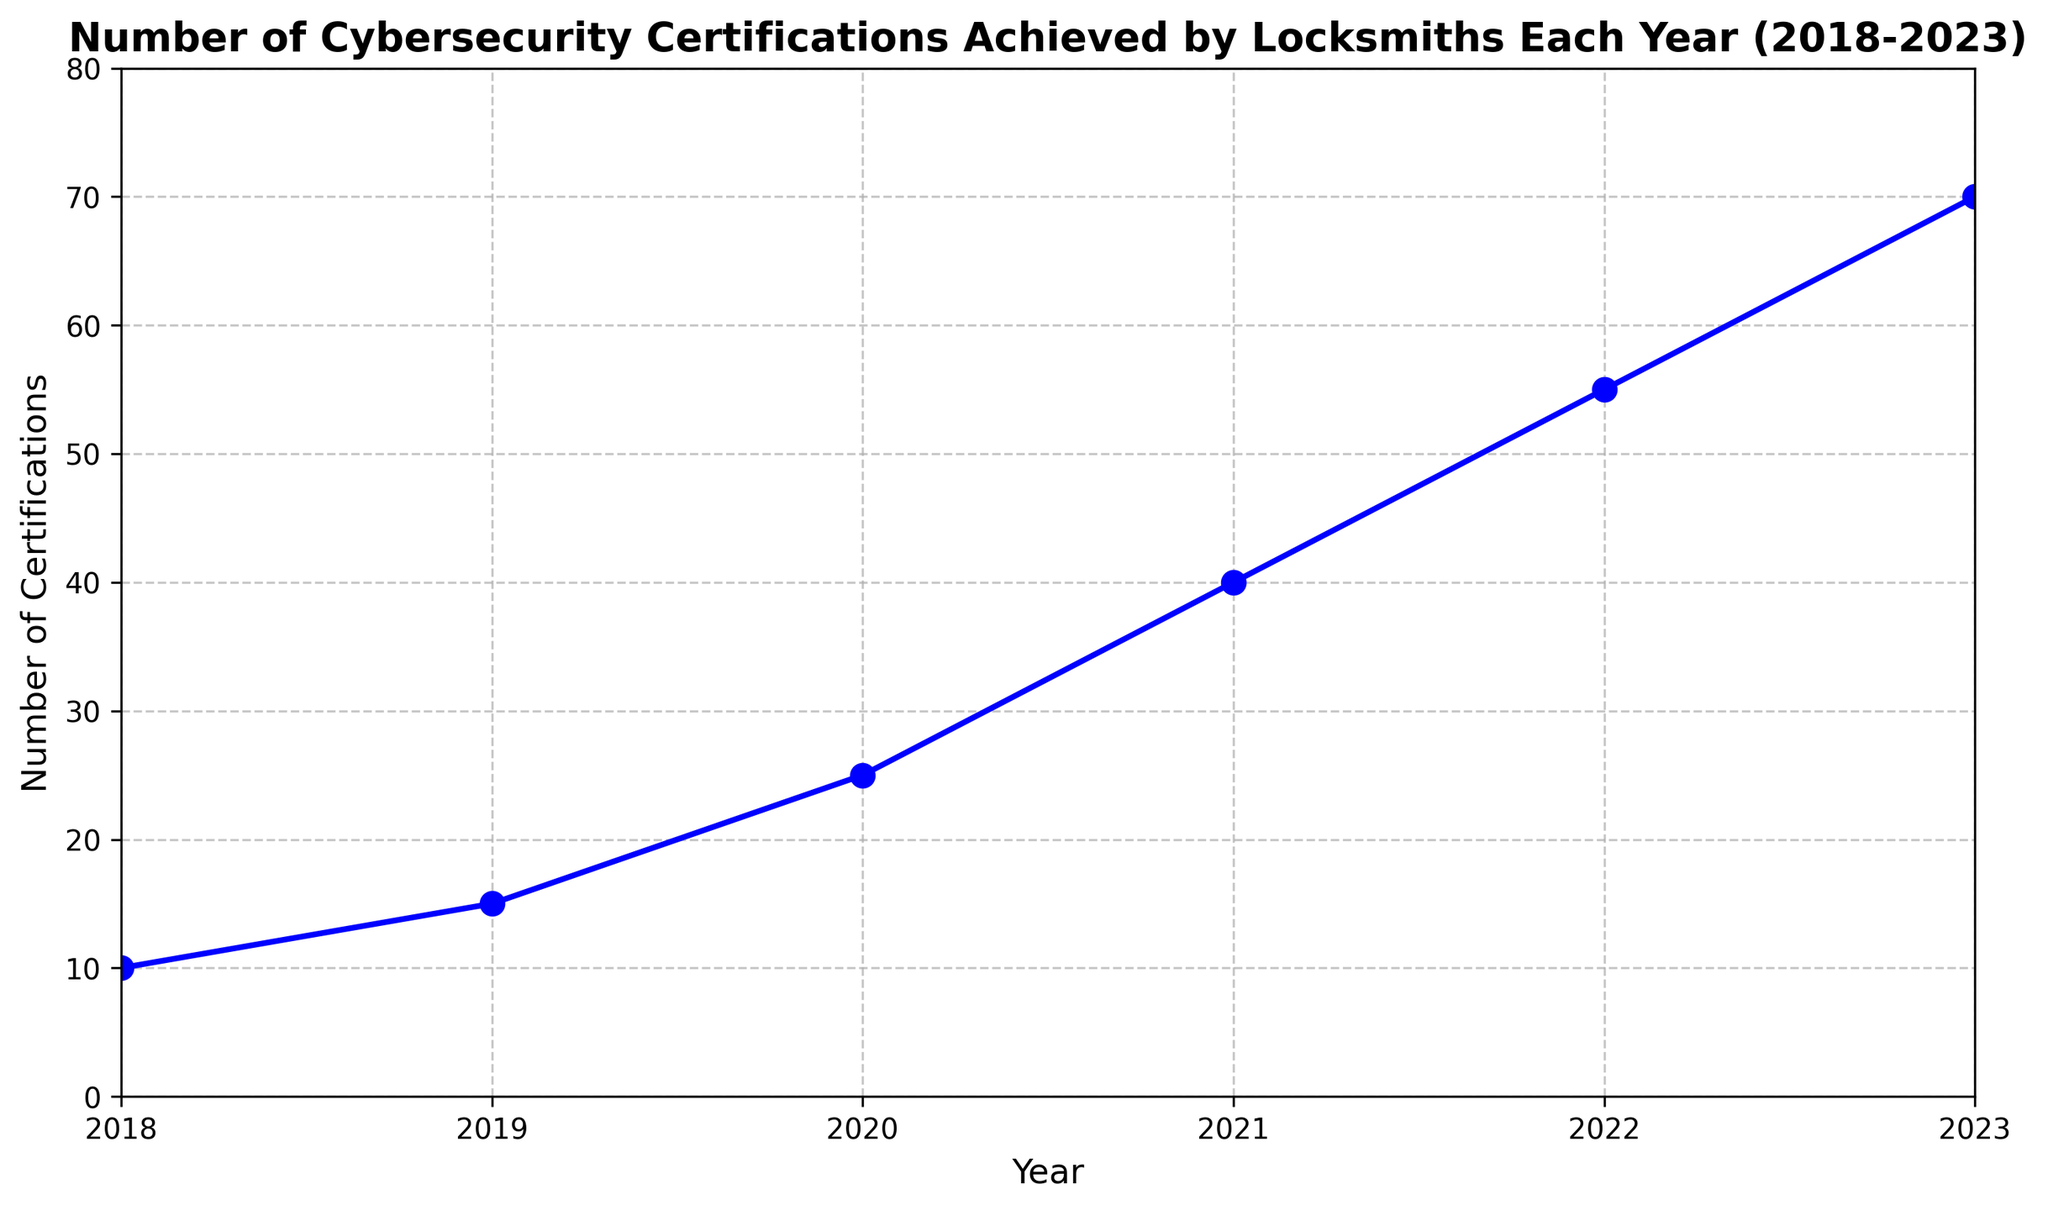What's the average number of certifications achieved per year from 2018 to 2023? To find the average number of certifications achieved per year from 2018 to 2023, sum up the values (10 + 15 + 25 + 40 + 55 + 70) = 215, then divide by the number of years, which is 6. Thus, 215 / 6 = approximately 35.83
Answer: 35.83 Which year had the greatest increase in certifications compared to the previous year? The increases each year are calculated as follows: (2019-2018) 15-10 = 5, (2020-2019) 25-15 = 10, (2021-2020) 40-25 = 15, (2022-2021) 55-40 = 15, (2023-2022) 70-55 = 15. The greatest increase occurred in 2021, 2022, and 2023, each with 15 certifications.
Answer: 2021, 2022, 2023 How many more certifications were achieved in 2020 compared to 2018? Subtract the number of certifications in 2018 from the number in 2020: 25 - 10 = 15. Therefore, 15 more certifications were achieved in 2020 compared to 2018
Answer: 15 What was the total number of certifications achieved in the first three years (2018-2020)? Sum the number of certifications from 2018, 2019, and 2020: 10 + 15 + 25 = 50. So, the total number for the first three years is 50
Answer: 50 What is the trend of the number of certifications over the years 2018 to 2023? The trend appears to be an increasing number of certifications each year, as each subsequent year shows a higher number of certifications than the previous year. Specifically, it increases from 10 in 2018 to 70 in 2023
Answer: Increasing Is the increase in certifications from 2021 to 2022 more than the increase from 2019 to 2020? Calculate the increases for each period: (2022-2021) 55-40 = 15 and (2020-2019) 25-15 = 10. Therefore, the increase from 2021 to 2022 (15) is greater than the increase from 2019 to 2020 (10)
Answer: Yes What visual element indicates a steady increase in certifications over time? The line on the chart consistently slopes upwards from 2018 to 2023 without any dips, indicating a steady increase in the number of certifications each year
Answer: Upward sloping line How much did the number of certifications increase by from 2020 to 2023? Subtract the number of certifications in 2020 from that in 2023: 70 - 25 = 45. So the number of certifications increased by 45 from 2020 to 2023
Answer: 45 